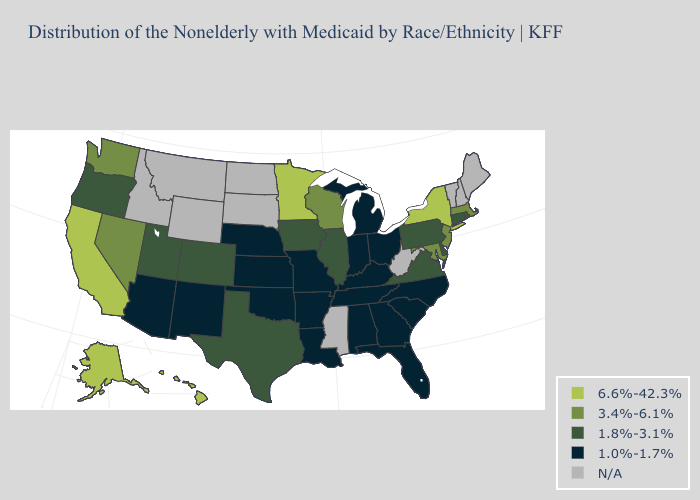What is the highest value in the USA?
Keep it brief. 6.6%-42.3%. What is the value of Arizona?
Be succinct. 1.0%-1.7%. What is the value of Illinois?
Quick response, please. 1.8%-3.1%. Name the states that have a value in the range 6.6%-42.3%?
Quick response, please. Alaska, California, Hawaii, Minnesota, New York. What is the value of Arizona?
Answer briefly. 1.0%-1.7%. What is the value of Mississippi?
Write a very short answer. N/A. Name the states that have a value in the range 1.0%-1.7%?
Concise answer only. Alabama, Arizona, Arkansas, Florida, Georgia, Indiana, Kansas, Kentucky, Louisiana, Michigan, Missouri, Nebraska, New Mexico, North Carolina, Ohio, Oklahoma, South Carolina, Tennessee. Which states have the lowest value in the USA?
Answer briefly. Alabama, Arizona, Arkansas, Florida, Georgia, Indiana, Kansas, Kentucky, Louisiana, Michigan, Missouri, Nebraska, New Mexico, North Carolina, Ohio, Oklahoma, South Carolina, Tennessee. What is the value of Connecticut?
Write a very short answer. 1.8%-3.1%. Does Washington have the lowest value in the West?
Give a very brief answer. No. Among the states that border Ohio , does Pennsylvania have the highest value?
Write a very short answer. Yes. What is the value of Tennessee?
Write a very short answer. 1.0%-1.7%. Does New York have the lowest value in the USA?
Give a very brief answer. No. 